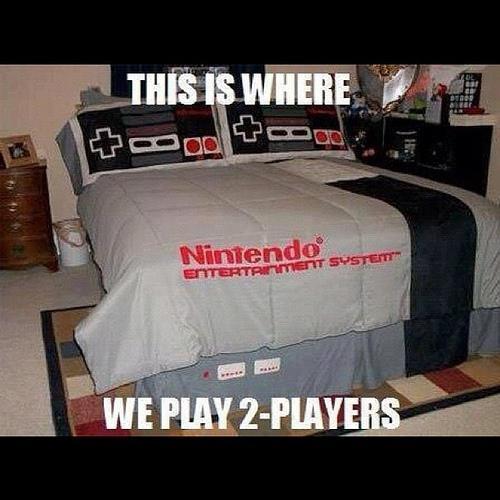How many pillows are on the bed?
Give a very brief answer. 2. 